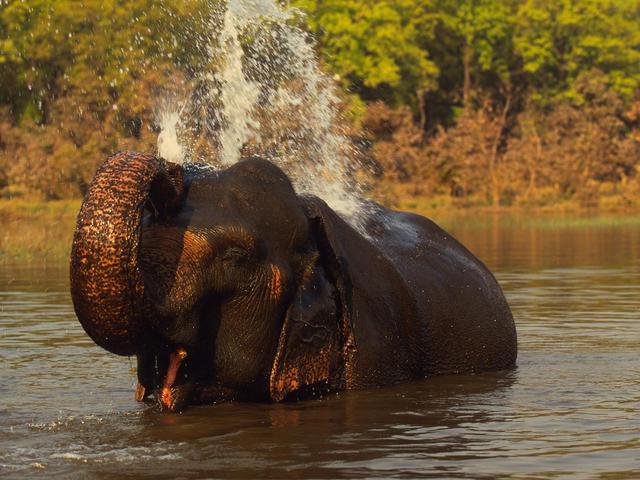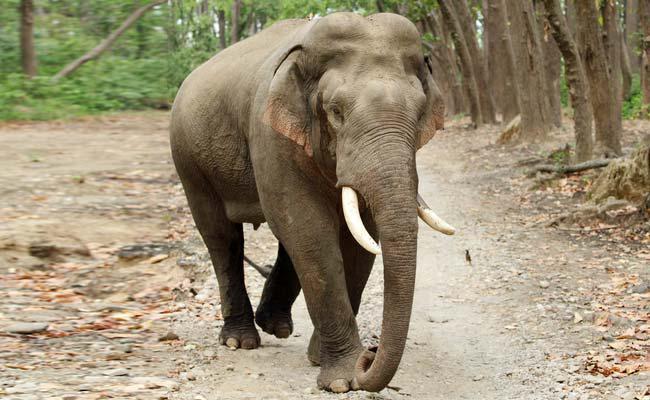The first image is the image on the left, the second image is the image on the right. Examine the images to the left and right. Is the description "A body of water is visible in one of the images." accurate? Answer yes or no. Yes. The first image is the image on the left, the second image is the image on the right. Examine the images to the left and right. Is the description "In one image, an elephant is in or near water." accurate? Answer yes or no. Yes. 